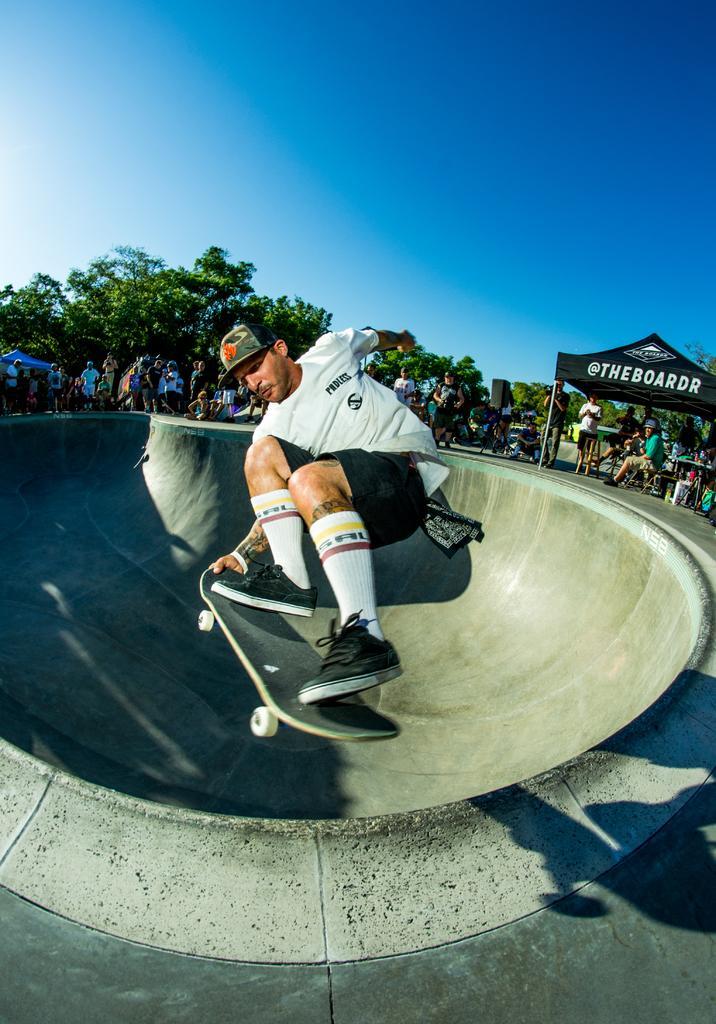How would you summarize this image in a sentence or two? In this picture we can see a man on the skateboard. Few people and trees are visible in the background. There is a tent on the right side. Sky is blue in color. 